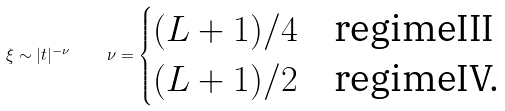<formula> <loc_0><loc_0><loc_500><loc_500>\xi \sim | t | ^ { - \nu } \quad \nu = \begin{cases} ( L + 1 ) / 4 & \text {regimeIII} \\ ( L + 1 ) / 2 & \text {regimeIV.} \end{cases}</formula> 